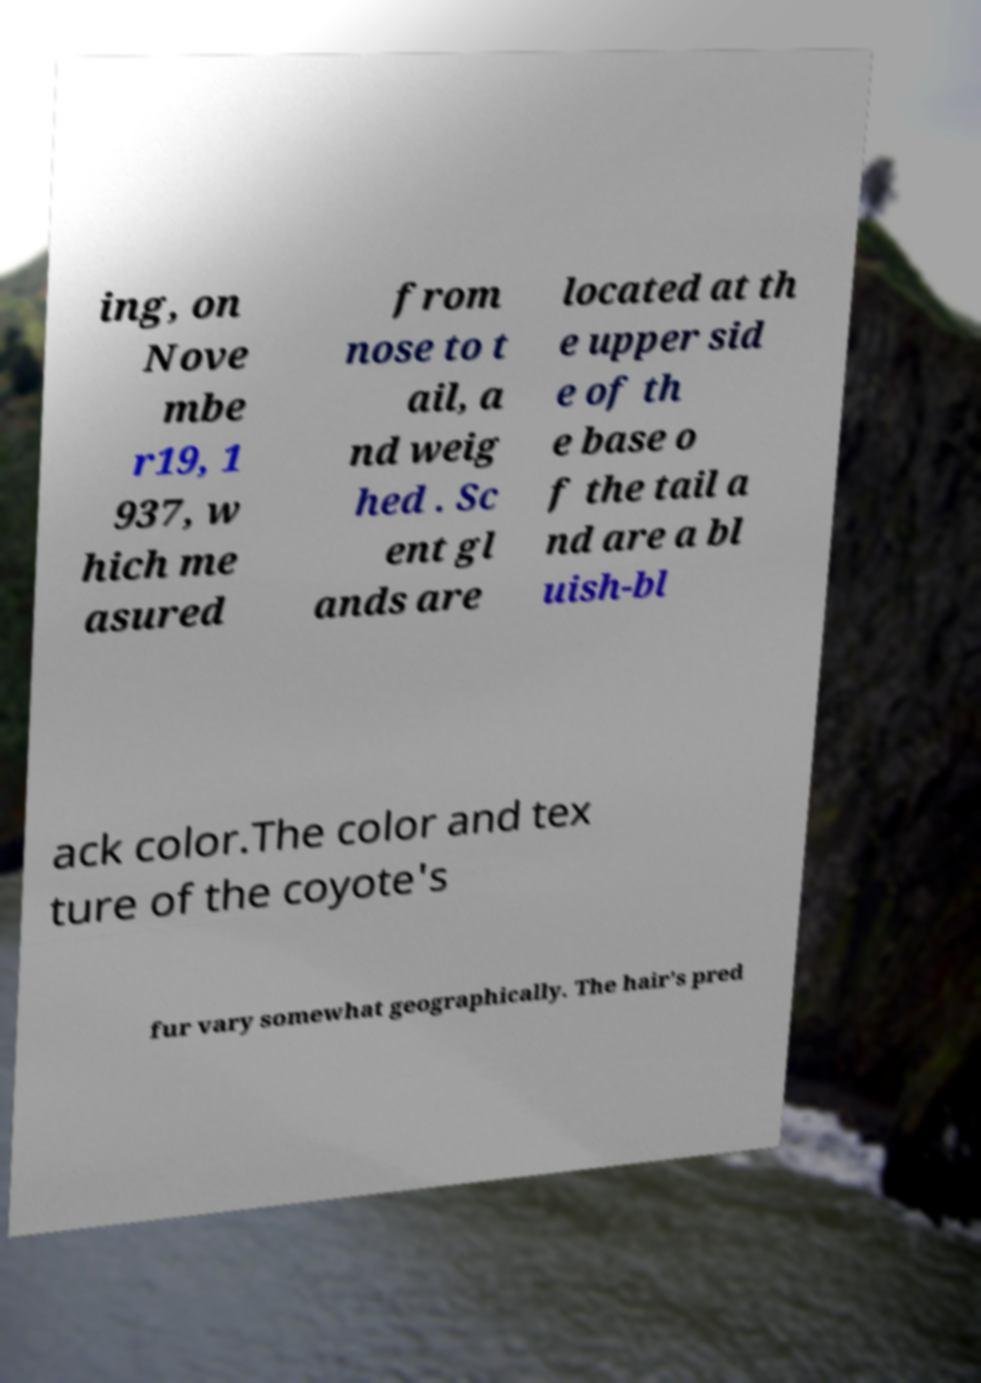What messages or text are displayed in this image? I need them in a readable, typed format. ing, on Nove mbe r19, 1 937, w hich me asured from nose to t ail, a nd weig hed . Sc ent gl ands are located at th e upper sid e of th e base o f the tail a nd are a bl uish-bl ack color.The color and tex ture of the coyote's fur vary somewhat geographically. The hair's pred 